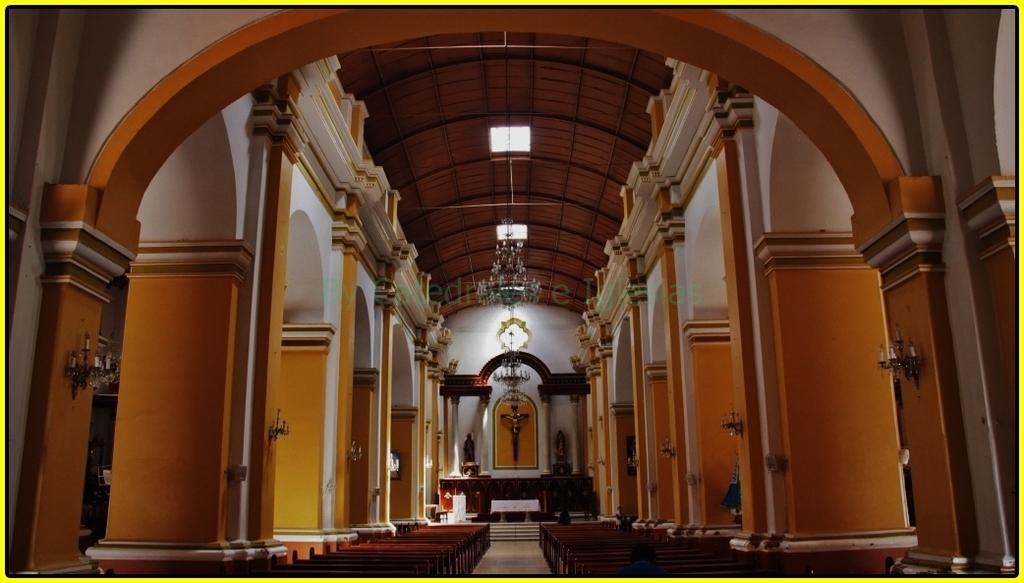In one or two sentences, can you explain what this image depicts? It is the picture of a church, inside the church most of the benches are empty and in the front there is a Jesus sculpture and around the hall there are plenty of pillars and many lights are attached to those pillars. 